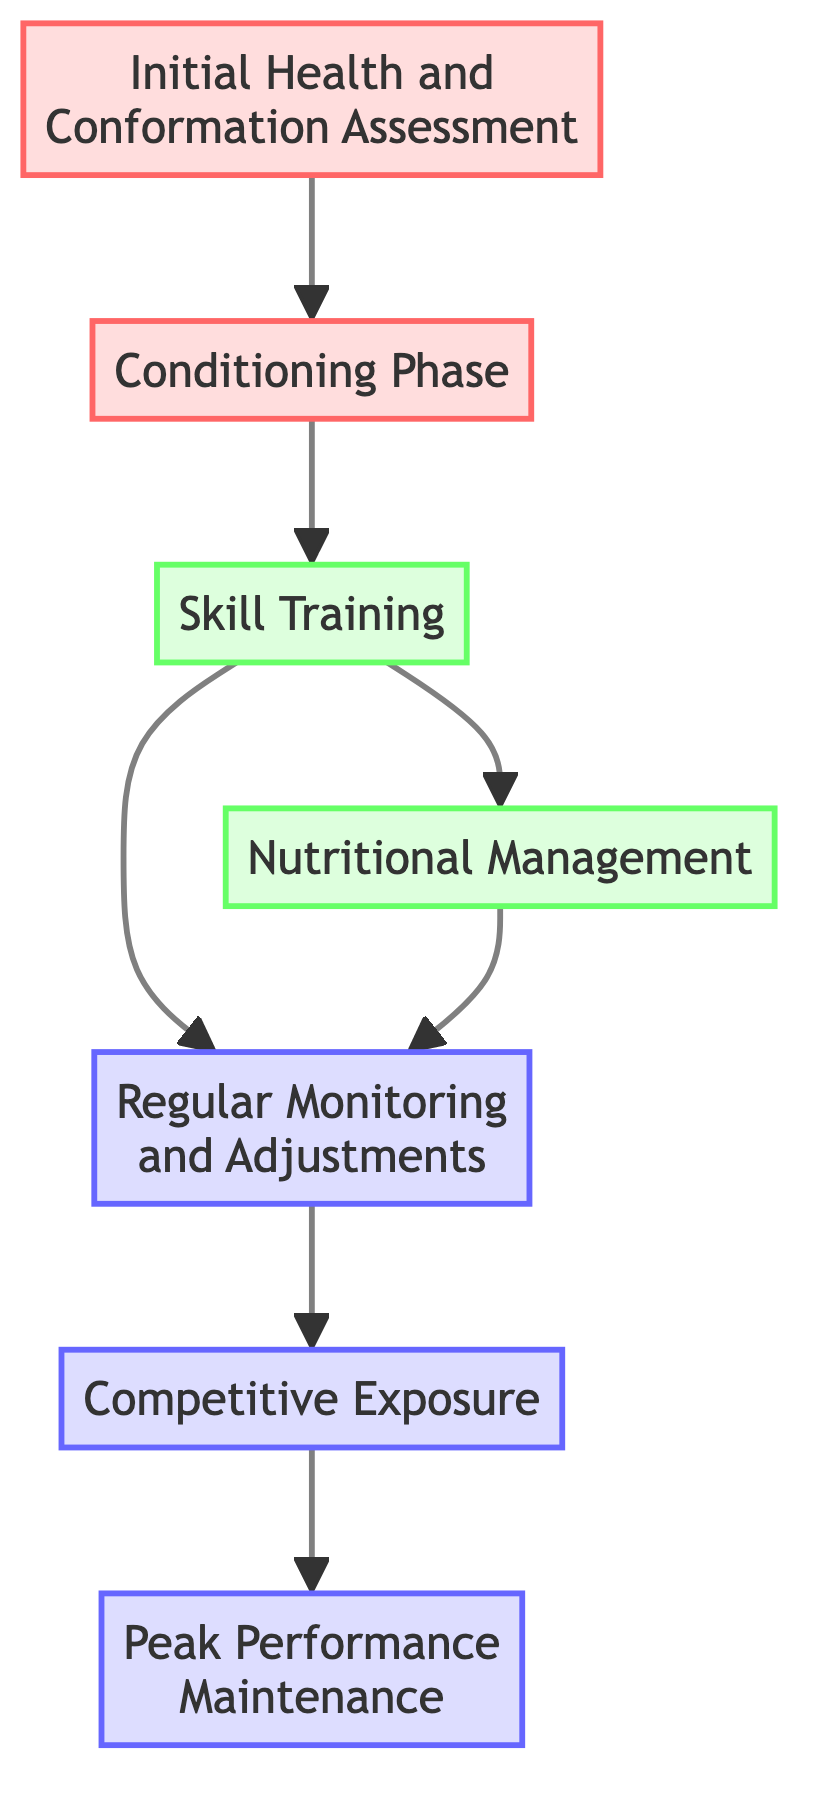What is the first step in the training process? The first step in the training process is the "Initial Health and Conformation Assessment" which assesses the horse's physical condition.
Answer: Initial Health and Conformation Assessment How many total steps are there in the diagram? Counting all the unique steps listed, there are 7 total steps in the training process.
Answer: 7 What step follows the "Conditioning Phase"? After the "Conditioning Phase," the next step is "Skill Training," which focuses on specific exercises.
Answer: Skill Training Which step requires adjustments based on ongoing assessments? The "Regular Monitoring and Adjustments" step requires continuous assessment of progress and adjustments to the training.
Answer: Regular Monitoring and Adjustments What are the two steps that come after "Skill Training"? Following "Skill Training," there are two branches leading to "Nutritional Management" and "Regular Monitoring and Adjustments" which are concurrent steps.
Answer: Nutritional Management and Regular Monitoring and Adjustments Which step is directly before "Peak Performance Maintenance"? The step directly before "Peak Performance Maintenance" is "Competitive Exposure," which prepares the horse for actual racing conditions.
Answer: Competitive Exposure What is the last step in the training process? The last step in the training process is "Peak Performance Maintenance," which focuses on maintaining the horse's top performance.
Answer: Peak Performance Maintenance Which step involves implementing a tailored diet plan? The step that involves implementing a tailored diet plan is "Nutritional Management," which addresses the energy demands of race training.
Answer: Nutritional Management What are the prerequisite steps for "Competitive Exposure"? The prerequisite step for "Competitive Exposure" is "Regular Monitoring and Adjustments," which is necessary to assess the horse’s readiness for competitive scenarios.
Answer: Regular Monitoring and Adjustments 